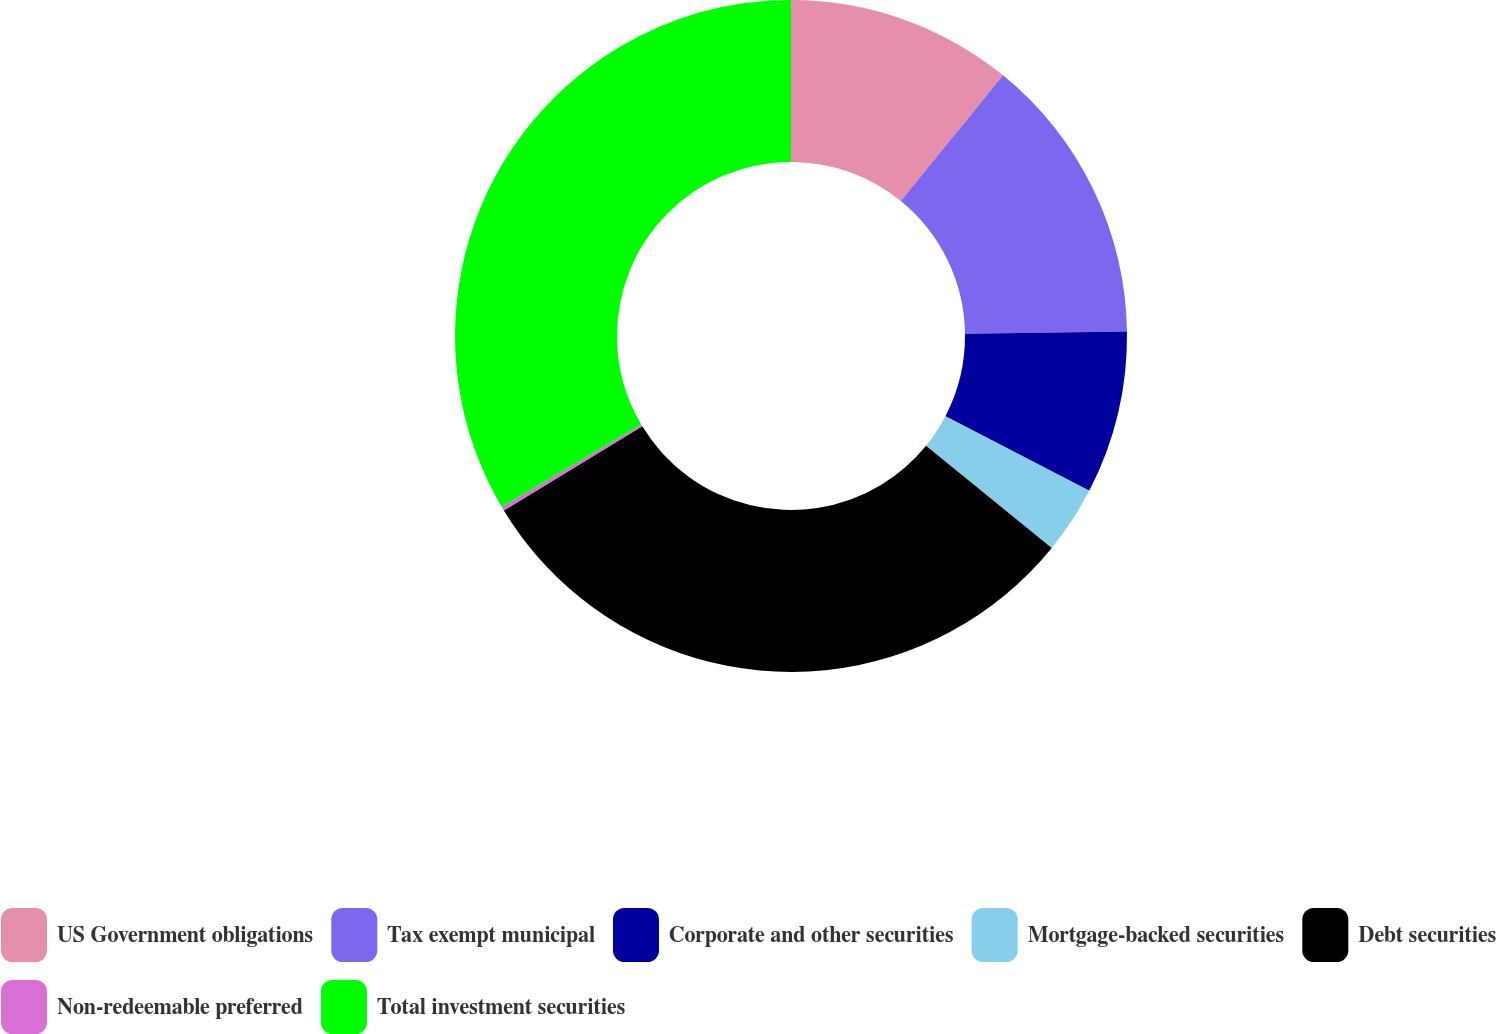<chart> <loc_0><loc_0><loc_500><loc_500><pie_chart><fcel>US Government obligations<fcel>Tax exempt municipal<fcel>Corporate and other securities<fcel>Mortgage-backed securities<fcel>Debt securities<fcel>Non-redeemable preferred<fcel>Total investment securities<nl><fcel>10.87%<fcel>13.92%<fcel>7.83%<fcel>3.24%<fcel>30.45%<fcel>0.19%<fcel>33.5%<nl></chart> 